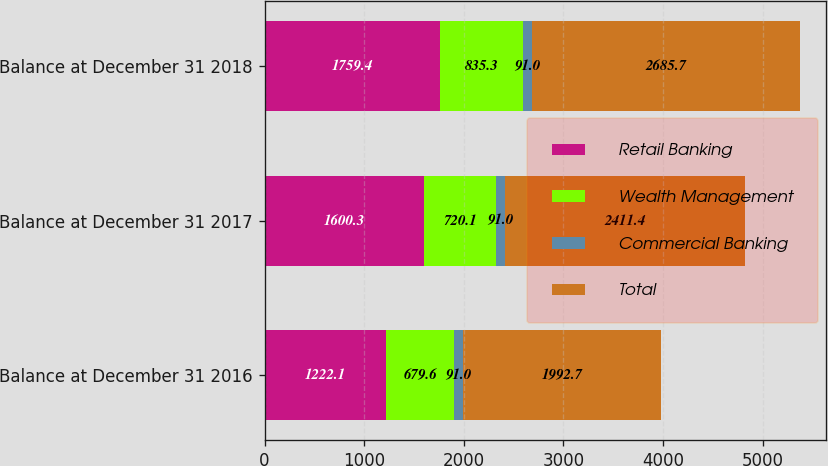Convert chart to OTSL. <chart><loc_0><loc_0><loc_500><loc_500><stacked_bar_chart><ecel><fcel>Balance at December 31 2016<fcel>Balance at December 31 2017<fcel>Balance at December 31 2018<nl><fcel>Retail Banking<fcel>1222.1<fcel>1600.3<fcel>1759.4<nl><fcel>Wealth Management<fcel>679.6<fcel>720.1<fcel>835.3<nl><fcel>Commercial Banking<fcel>91<fcel>91<fcel>91<nl><fcel>Total<fcel>1992.7<fcel>2411.4<fcel>2685.7<nl></chart> 